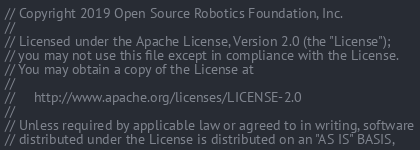<code> <loc_0><loc_0><loc_500><loc_500><_C++_>// Copyright 2019 Open Source Robotics Foundation, Inc.
//
// Licensed under the Apache License, Version 2.0 (the "License");
// you may not use this file except in compliance with the License.
// You may obtain a copy of the License at
//
//     http://www.apache.org/licenses/LICENSE-2.0
//
// Unless required by applicable law or agreed to in writing, software
// distributed under the License is distributed on an "AS IS" BASIS,</code> 